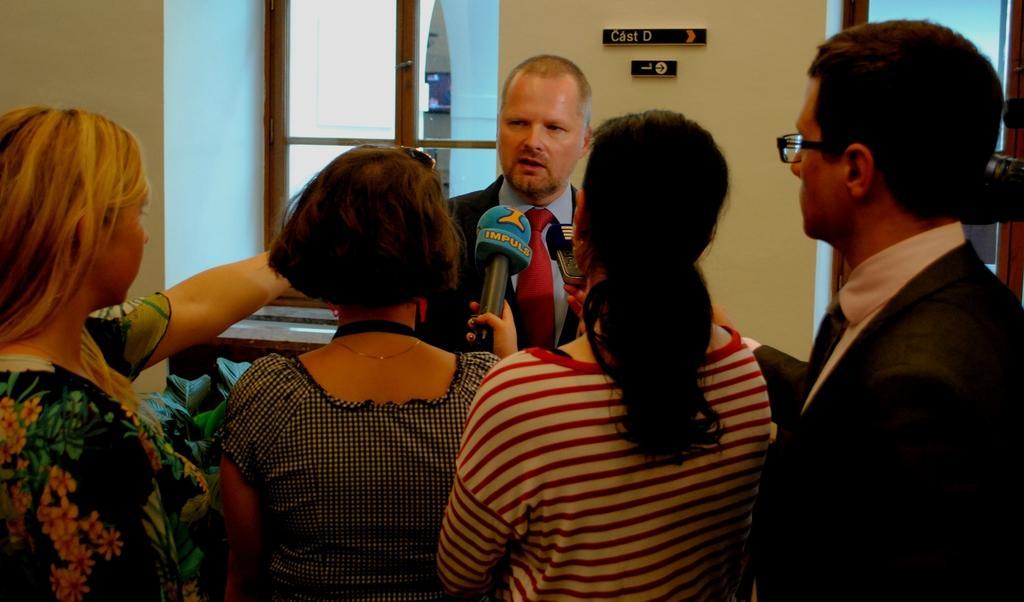Please provide a concise description of this image. In this image we can see a group of people standing. In that a woman is holding a mic and the other is holding a device. On the backside we can see some boards on a wall and some windows. 